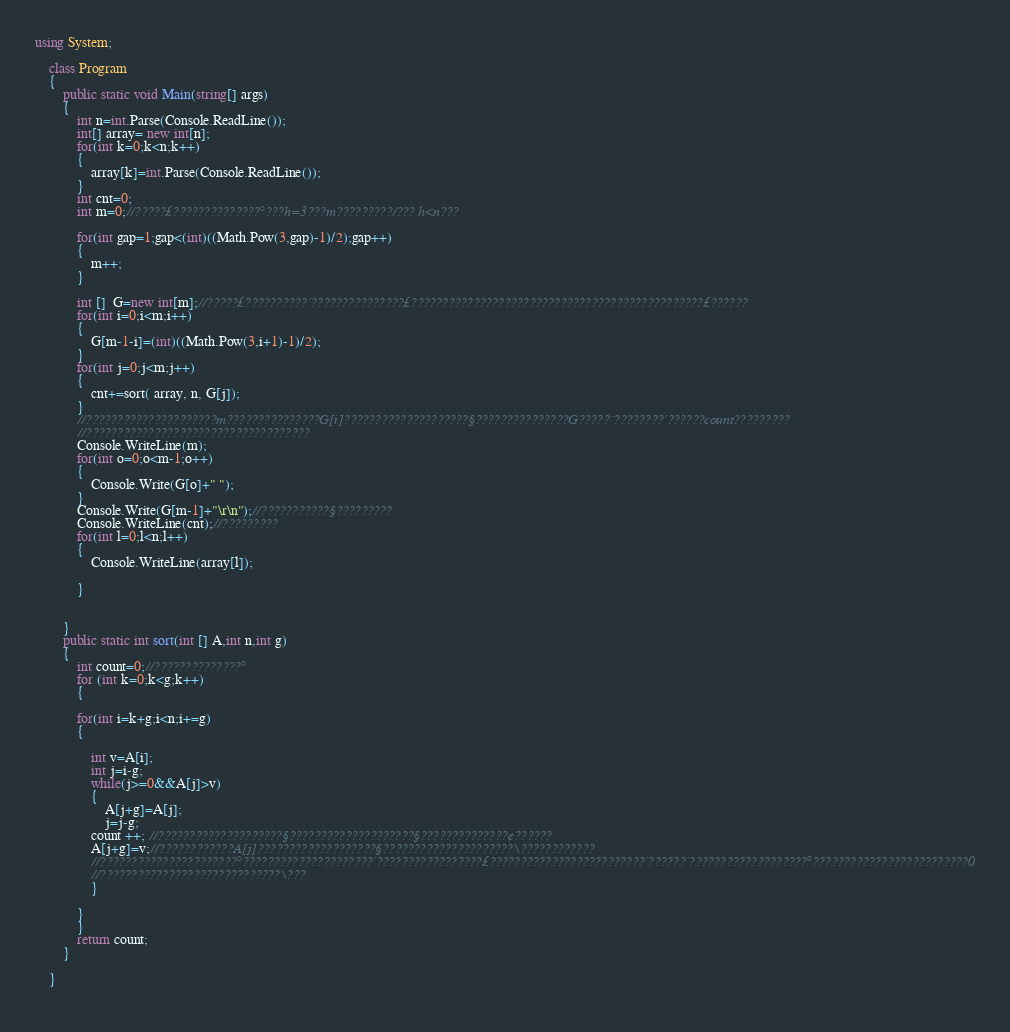<code> <loc_0><loc_0><loc_500><loc_500><_C#_>using System;

	class Program
	{
		public static void Main(string[] args)
		{
			int n=int.Parse(Console.ReadLine());
			int[] array= new int[n];
			for(int k=0;k<n;k++)
			{
				array[k]=int.Parse(Console.ReadLine());
			}
			int cnt=0;
			int m=0;//?????£??????????????°???h=3???m?????????/??? h<n???

			for(int gap=1;gap<(int)((Math.Pow(3,gap)-1)/2);gap++)
			{			
				m++;
			}
			
			int []  G=new int[m];//?????£??????????´???????????????£???????????????????????????????????????????????£??????
			for(int i=0;i<m;i++)
			{
				G[m-1-i]=(int)((Math.Pow(3,i+1)-1)/2);
			}
			for(int j=0;j<m;j++)
			{
				cnt+=sort( array, n, G[j]);
			}
			//?????????????????????m???????????????G[i]????????????????????§???????????????G?????¨????????´??????count?????????
			//????????????????????????????????????
			Console.WriteLine(m);
			for(int o=0;o<m-1;o++)
			{
				Console.Write(G[o]+" ");
			}
			Console.Write(G[m-1]+"\r\n");//???????????§?????????
			Console.WriteLine(cnt);//?????????
			for(int l=0;l<n;l++)
			{
				Console.WriteLine(array[l]);
			
			}
			
			
		}
		public static int sort(int [] A,int n,int g)
		{
			int count=0;//??????????????°
			for (int k=0;k<g;k++)
			{
				
			for(int i=k+g;i<n;i+=g)
			{
				
				int v=A[i];
				int j=i-g;
				while(j>=0&&A[j]>v)
				{
					A[j+g]=A[j];
					j=j-g;
				count ++; //????????????????????§????????????????????§??????????????¢??????
				A[j+g]=v;//????????????A[j]???????????????????§?????????????????????\????????????
				//??????????????????????°?????????????????????´?????????????????£?????????????????????????´??????´???????????????????°?????????????????????????0
				//?????????????????????????????\???
				}
				
			}
			}
			return count;
		}
		
	}
	</code> 